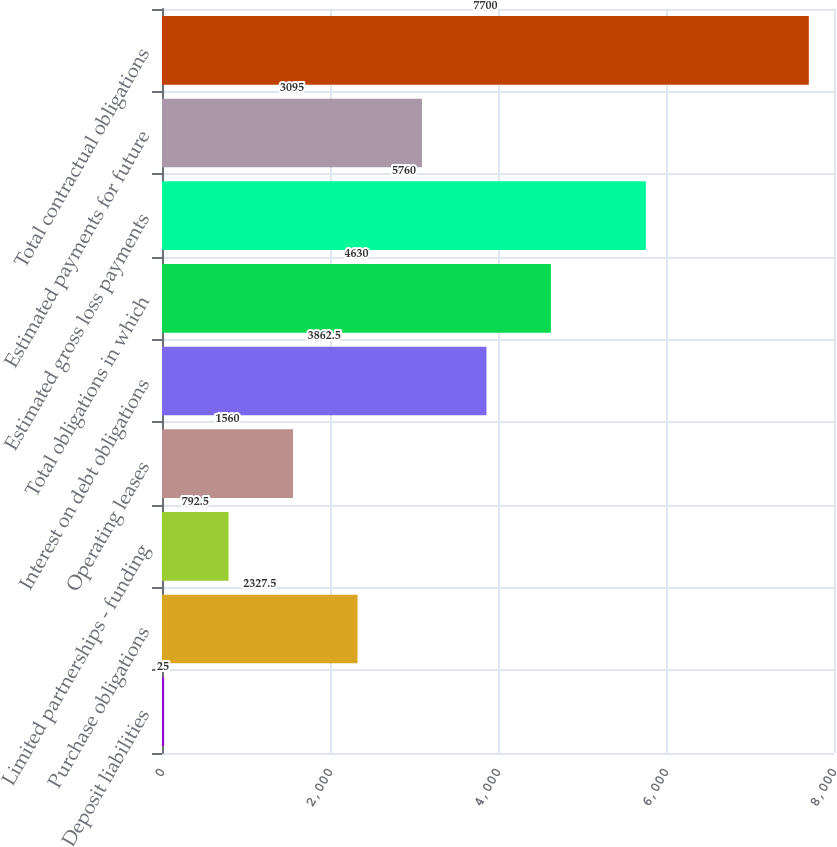Convert chart. <chart><loc_0><loc_0><loc_500><loc_500><bar_chart><fcel>Deposit liabilities<fcel>Purchase obligations<fcel>Limited partnerships - funding<fcel>Operating leases<fcel>Interest on debt obligations<fcel>Total obligations in which<fcel>Estimated gross loss payments<fcel>Estimated payments for future<fcel>Total contractual obligations<nl><fcel>25<fcel>2327.5<fcel>792.5<fcel>1560<fcel>3862.5<fcel>4630<fcel>5760<fcel>3095<fcel>7700<nl></chart> 